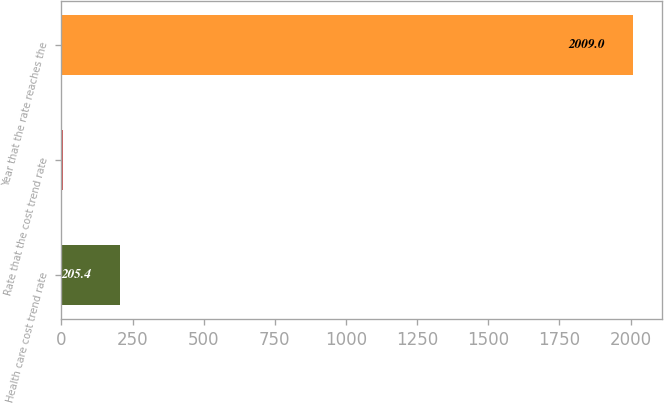<chart> <loc_0><loc_0><loc_500><loc_500><bar_chart><fcel>Health care cost trend rate<fcel>Rate that the cost trend rate<fcel>Year that the rate reaches the<nl><fcel>205.4<fcel>5<fcel>2009<nl></chart> 